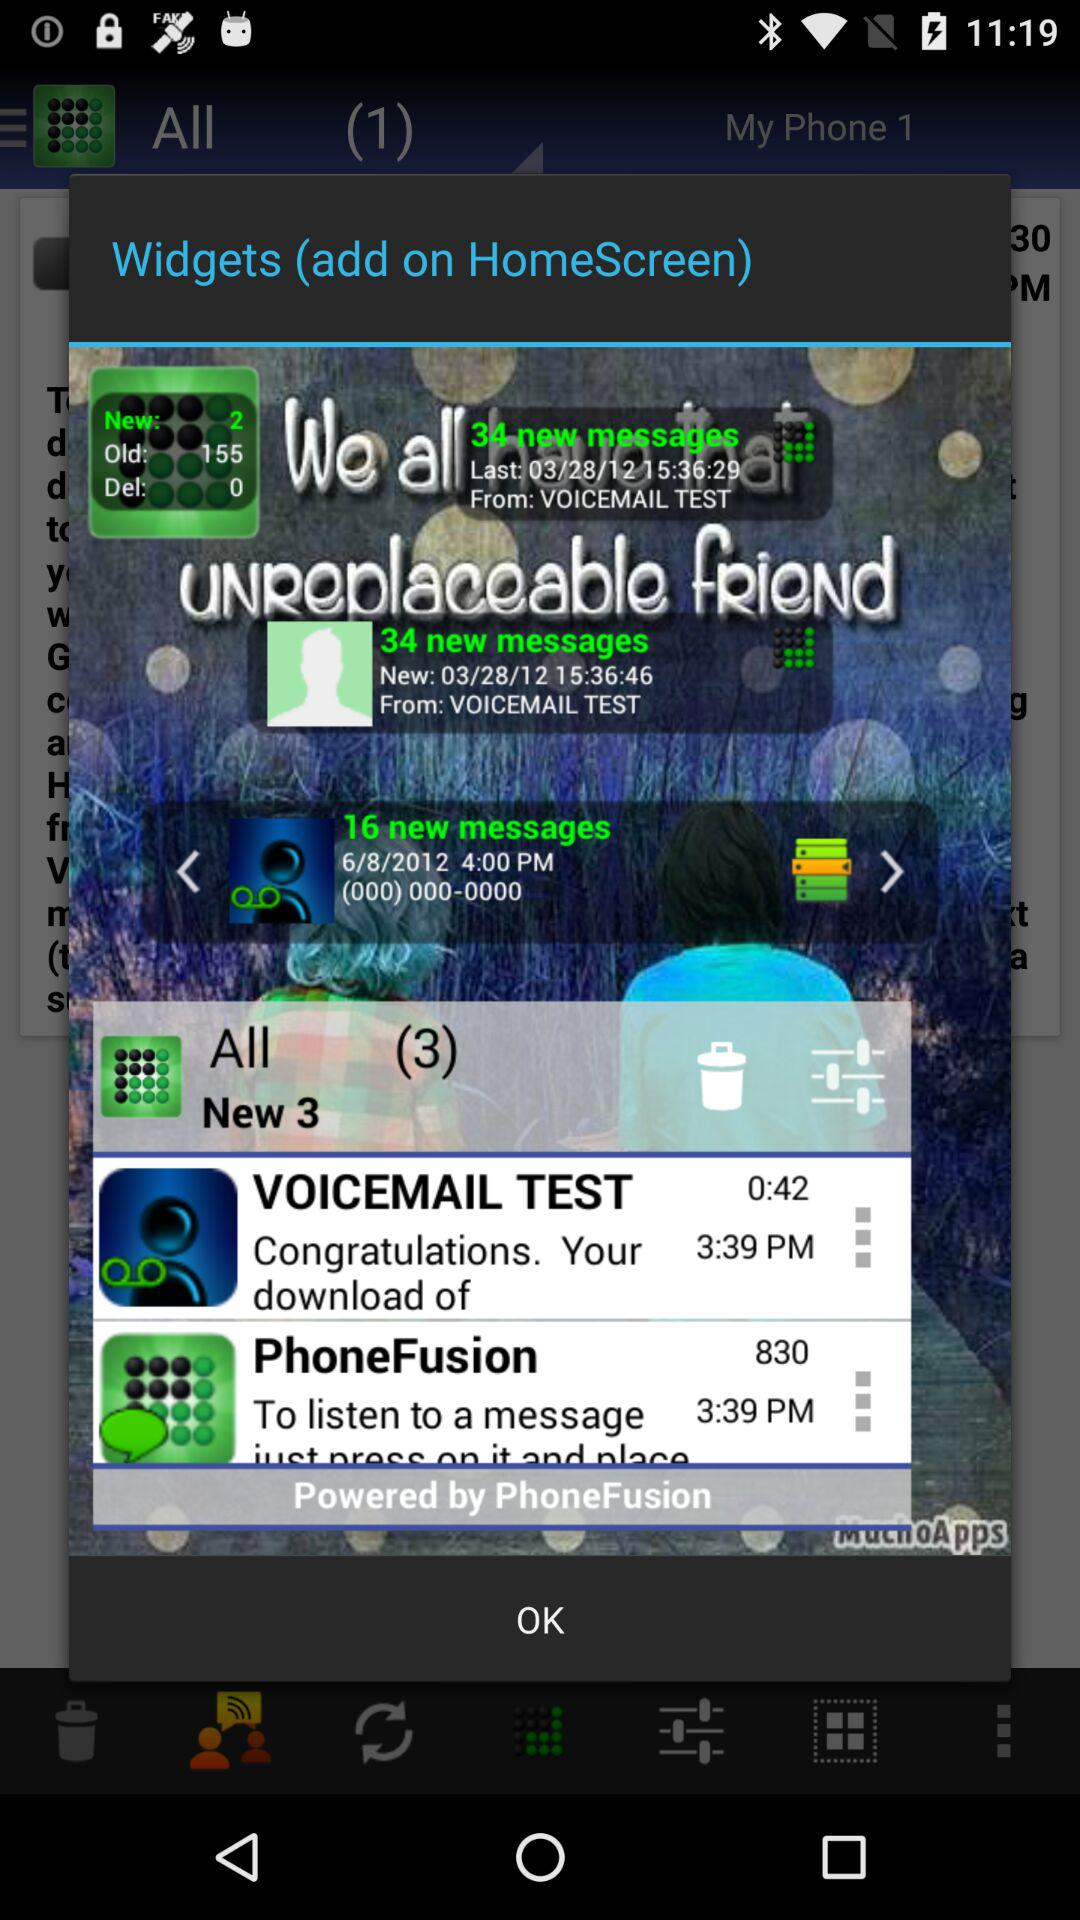How many total messages are from PhoneFusion?
When the provided information is insufficient, respond with <no answer>. <no answer> 